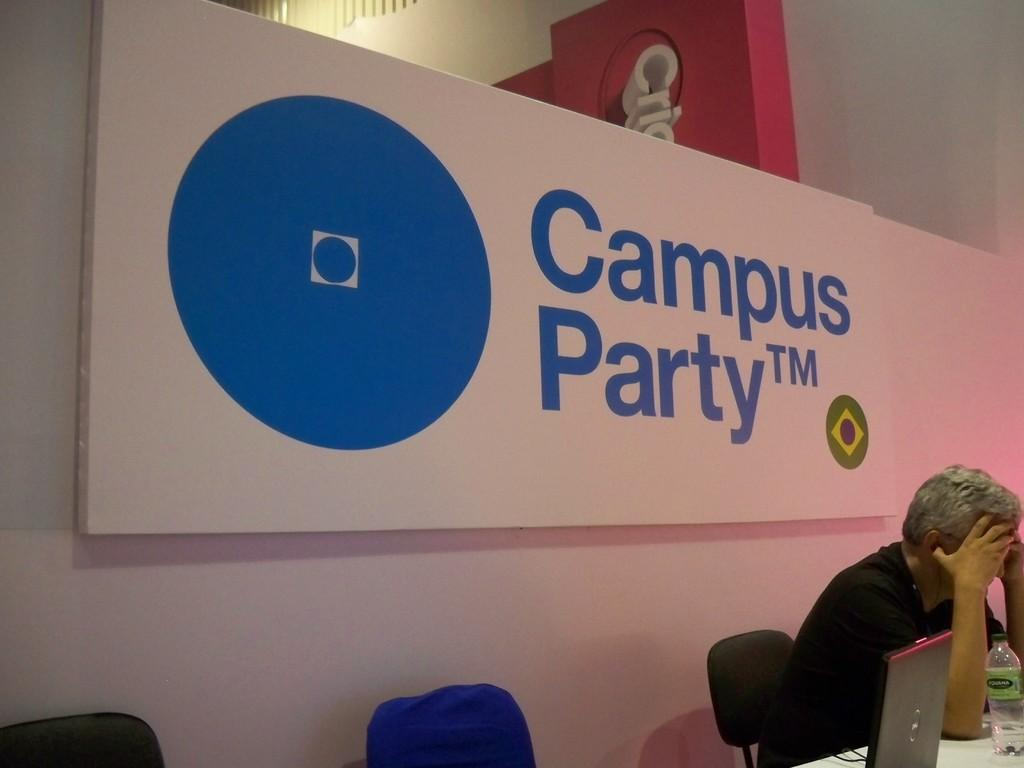What is displayed on the name board in the image? The name board in the image has patent rights and a trade mark. What is the person in the image doing? The person is sitting in a chair. What electronic device is visible in the image? There is a laptop in the image. What type of container is present in the image? There is a bottle in the image. What piece of furniture is used for sitting in the image? There is a chair in the image. What surface is used for placing objects in the image? There is a table in the image. Where is the lettuce located in the image? There is no lettuce present in the image. How many legs does the fact have in the image? There is no fact present in the image, and therefore no legs can be counted. 